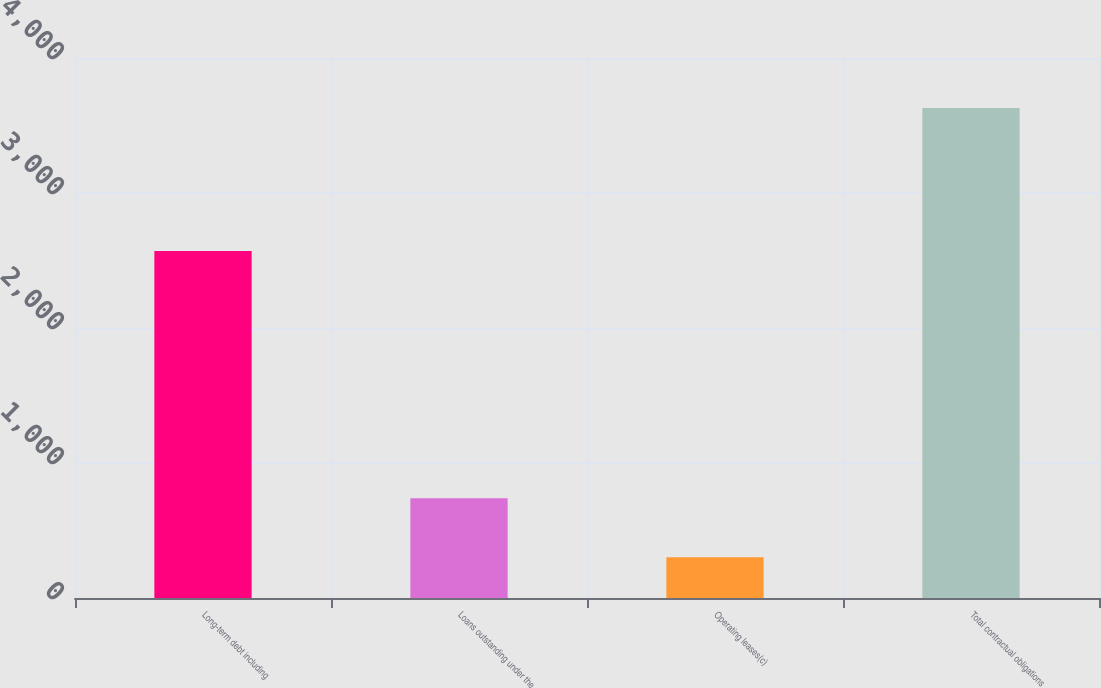Convert chart. <chart><loc_0><loc_0><loc_500><loc_500><bar_chart><fcel>Long-term debt including<fcel>Loans outstanding under the<fcel>Operating leases(c)<fcel>Total contractual obligations<nl><fcel>2570<fcel>739<fcel>301<fcel>3629<nl></chart> 